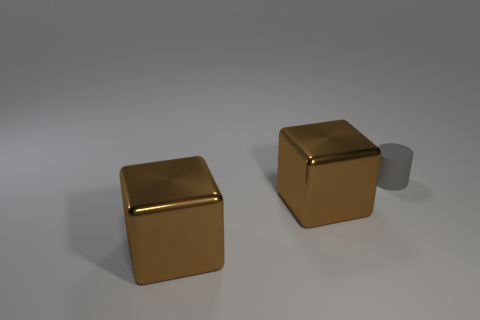How many other objects are the same material as the small cylinder?
Provide a succinct answer. 0. Are there any brown metal things in front of the small matte cylinder?
Give a very brief answer. Yes. How big is the gray matte cylinder?
Offer a very short reply. Small. Is the number of small cylinders greater than the number of brown metallic things?
Your answer should be very brief. No. The tiny rubber object has what shape?
Keep it short and to the point. Cylinder. Is there anything else that has the same size as the matte cylinder?
Provide a short and direct response. No. Are there more gray cylinders that are in front of the small gray rubber cylinder than big things?
Give a very brief answer. No. Is the number of small gray objects on the left side of the small object the same as the number of matte objects?
Offer a very short reply. No. How many cubes are shiny things or small gray things?
Keep it short and to the point. 2. What number of objects are large blue shiny balls or metallic cubes?
Make the answer very short. 2. 